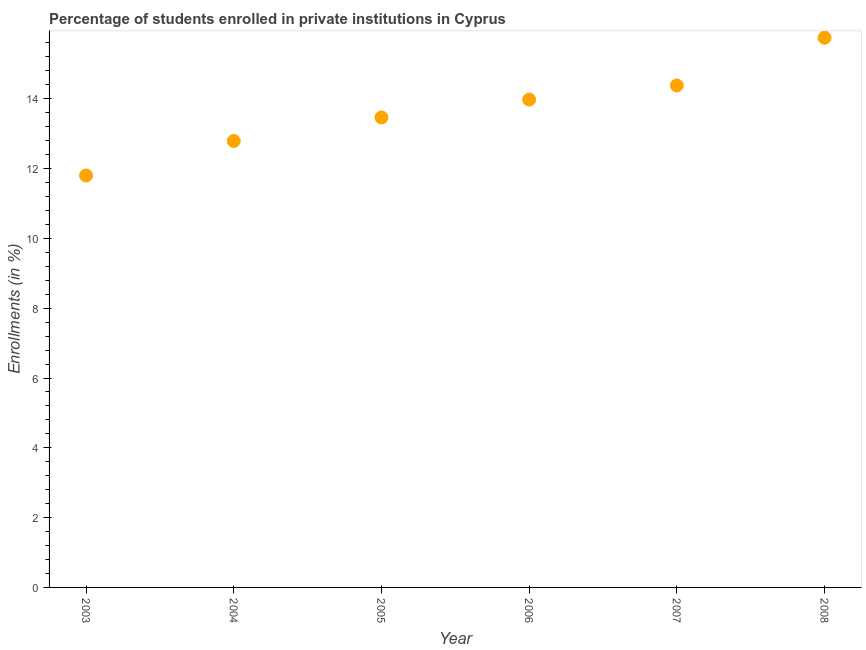What is the enrollments in private institutions in 2005?
Your answer should be very brief. 13.47. Across all years, what is the maximum enrollments in private institutions?
Keep it short and to the point. 15.75. Across all years, what is the minimum enrollments in private institutions?
Give a very brief answer. 11.8. In which year was the enrollments in private institutions maximum?
Provide a succinct answer. 2008. In which year was the enrollments in private institutions minimum?
Provide a short and direct response. 2003. What is the sum of the enrollments in private institutions?
Keep it short and to the point. 82.18. What is the difference between the enrollments in private institutions in 2006 and 2007?
Offer a very short reply. -0.4. What is the average enrollments in private institutions per year?
Keep it short and to the point. 13.7. What is the median enrollments in private institutions?
Give a very brief answer. 13.72. In how many years, is the enrollments in private institutions greater than 0.4 %?
Your response must be concise. 6. Do a majority of the years between 2007 and 2003 (inclusive) have enrollments in private institutions greater than 2 %?
Give a very brief answer. Yes. What is the ratio of the enrollments in private institutions in 2003 to that in 2004?
Your answer should be compact. 0.92. Is the enrollments in private institutions in 2004 less than that in 2007?
Offer a terse response. Yes. What is the difference between the highest and the second highest enrollments in private institutions?
Offer a very short reply. 1.37. Is the sum of the enrollments in private institutions in 2004 and 2008 greater than the maximum enrollments in private institutions across all years?
Keep it short and to the point. Yes. What is the difference between the highest and the lowest enrollments in private institutions?
Provide a short and direct response. 3.95. In how many years, is the enrollments in private institutions greater than the average enrollments in private institutions taken over all years?
Offer a very short reply. 3. Does the enrollments in private institutions monotonically increase over the years?
Your answer should be very brief. Yes. How many years are there in the graph?
Ensure brevity in your answer.  6. What is the difference between two consecutive major ticks on the Y-axis?
Offer a terse response. 2. Are the values on the major ticks of Y-axis written in scientific E-notation?
Your answer should be very brief. No. Does the graph contain any zero values?
Keep it short and to the point. No. What is the title of the graph?
Give a very brief answer. Percentage of students enrolled in private institutions in Cyprus. What is the label or title of the Y-axis?
Keep it short and to the point. Enrollments (in %). What is the Enrollments (in %) in 2003?
Offer a very short reply. 11.8. What is the Enrollments (in %) in 2004?
Give a very brief answer. 12.79. What is the Enrollments (in %) in 2005?
Make the answer very short. 13.47. What is the Enrollments (in %) in 2006?
Your answer should be compact. 13.98. What is the Enrollments (in %) in 2007?
Offer a terse response. 14.38. What is the Enrollments (in %) in 2008?
Offer a terse response. 15.75. What is the difference between the Enrollments (in %) in 2003 and 2004?
Your answer should be very brief. -0.99. What is the difference between the Enrollments (in %) in 2003 and 2005?
Ensure brevity in your answer.  -1.66. What is the difference between the Enrollments (in %) in 2003 and 2006?
Give a very brief answer. -2.18. What is the difference between the Enrollments (in %) in 2003 and 2007?
Give a very brief answer. -2.58. What is the difference between the Enrollments (in %) in 2003 and 2008?
Offer a very short reply. -3.95. What is the difference between the Enrollments (in %) in 2004 and 2005?
Your answer should be very brief. -0.67. What is the difference between the Enrollments (in %) in 2004 and 2006?
Your answer should be very brief. -1.19. What is the difference between the Enrollments (in %) in 2004 and 2007?
Keep it short and to the point. -1.59. What is the difference between the Enrollments (in %) in 2004 and 2008?
Make the answer very short. -2.96. What is the difference between the Enrollments (in %) in 2005 and 2006?
Ensure brevity in your answer.  -0.51. What is the difference between the Enrollments (in %) in 2005 and 2007?
Your answer should be compact. -0.92. What is the difference between the Enrollments (in %) in 2005 and 2008?
Ensure brevity in your answer.  -2.28. What is the difference between the Enrollments (in %) in 2006 and 2007?
Your response must be concise. -0.4. What is the difference between the Enrollments (in %) in 2006 and 2008?
Provide a succinct answer. -1.77. What is the difference between the Enrollments (in %) in 2007 and 2008?
Your answer should be compact. -1.37. What is the ratio of the Enrollments (in %) in 2003 to that in 2004?
Provide a succinct answer. 0.92. What is the ratio of the Enrollments (in %) in 2003 to that in 2005?
Offer a very short reply. 0.88. What is the ratio of the Enrollments (in %) in 2003 to that in 2006?
Provide a short and direct response. 0.84. What is the ratio of the Enrollments (in %) in 2003 to that in 2007?
Give a very brief answer. 0.82. What is the ratio of the Enrollments (in %) in 2003 to that in 2008?
Your answer should be compact. 0.75. What is the ratio of the Enrollments (in %) in 2004 to that in 2006?
Offer a terse response. 0.92. What is the ratio of the Enrollments (in %) in 2004 to that in 2007?
Offer a very short reply. 0.89. What is the ratio of the Enrollments (in %) in 2004 to that in 2008?
Offer a terse response. 0.81. What is the ratio of the Enrollments (in %) in 2005 to that in 2007?
Make the answer very short. 0.94. What is the ratio of the Enrollments (in %) in 2005 to that in 2008?
Your answer should be very brief. 0.85. What is the ratio of the Enrollments (in %) in 2006 to that in 2008?
Ensure brevity in your answer.  0.89. 